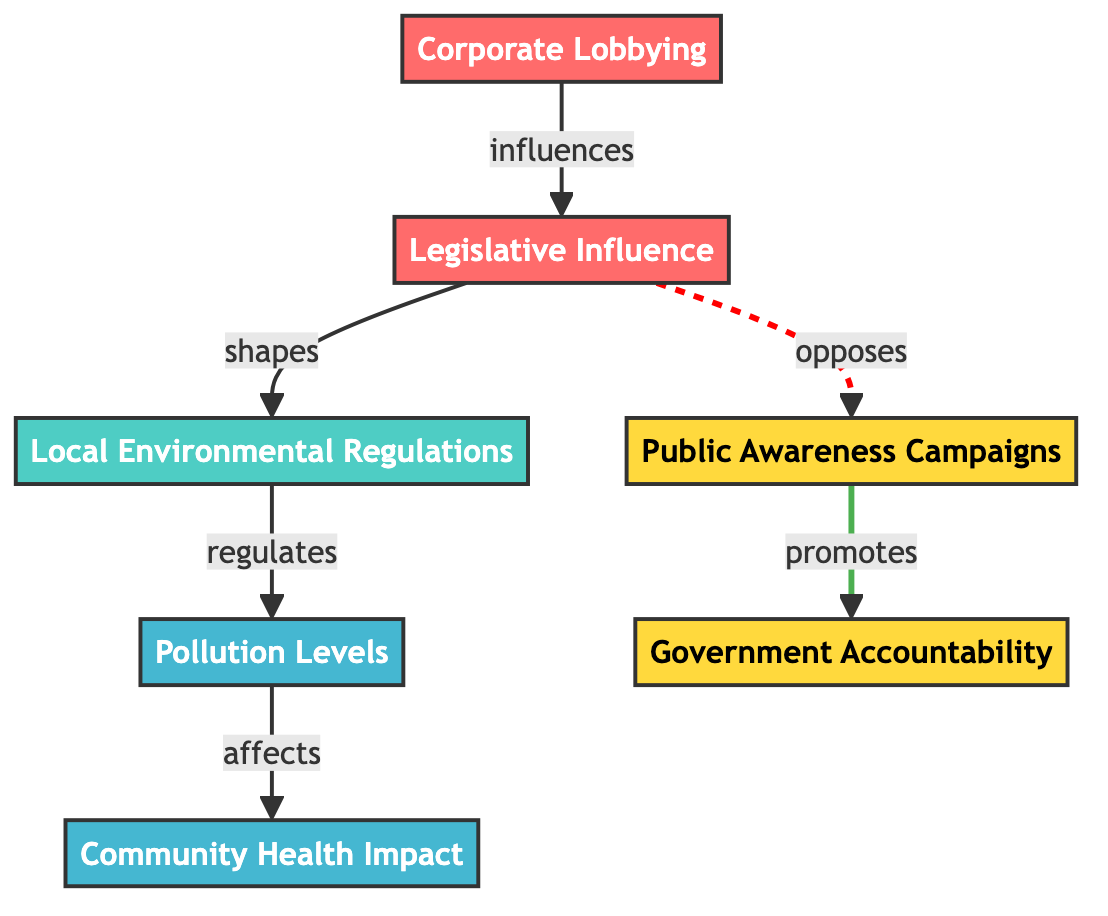What is the first node in the flowchart? The first node in the flowchart is "Corporate Lobbying." It is the starting point from which the other nodes connect, and it influences the legislative process.
Answer: Corporate Lobbying How many edges are in the flowchart? To find the number of edges, we count the connections. There are a total of 6 edges connecting the nodes together, showing relationships between them.
Answer: 6 What does "Legislative Influence" shape? "Legislative Influence" shapes "Local Environmental Regulations." This indicates the direct impact that legislative influence has on modifying or creating local regulations.
Answer: Local Environmental Regulations Which node is affected by "Pollution Levels"? The node that is affected by "Pollution Levels" is "Community Health Impact." This means that changes in pollution levels directly correlate to the health impacts observed in the community.
Answer: Community Health Impact What type of relationship exists between "Legislative Influence" and "Public Awareness Campaigns"? The relationship is an opposing one, indicated by the dashed line. "Legislative Influence" opposes "Public Awareness Campaigns," suggesting that legislative actions may work against or hinder these campaigns.
Answer: opposes What is the result of "Corporate Lobbying" on "Local Environmental Regulations"? "Corporate Lobbying" influences "Legislative Influence," which in turn shapes "Local Environmental Regulations." Therefore, the result is that corporate lobbying has a significant impact on how local regulations are formed.
Answer: Local Environmental Regulations What promotes "Government Accountability"? "Public Awareness Campaigns" promote "Government Accountability." This shows that increased public discourse and awareness can lead to greater accountability from government entities.
Answer: Government Accountability Identify the last node leading directly from "Pollution Levels." The last node leading directly from "Pollution Levels" is "Community Health Impact." This indicates that pollution levels have a direct implication on community health.
Answer: Community Health Impact 